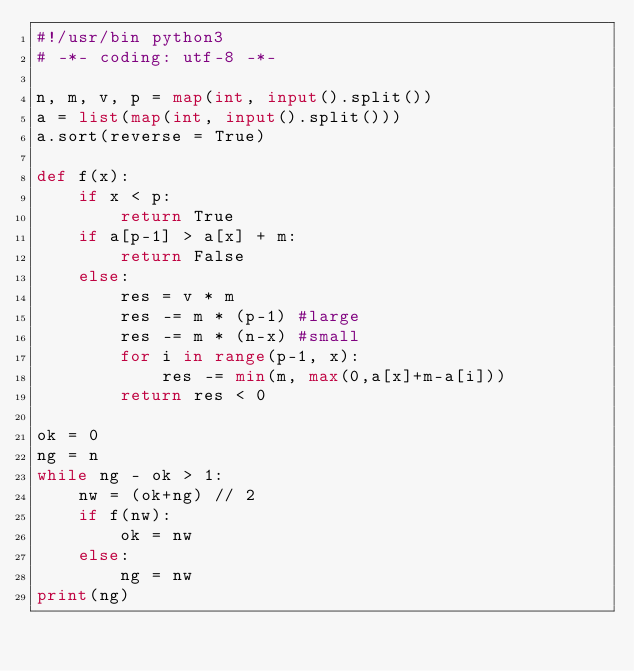Convert code to text. <code><loc_0><loc_0><loc_500><loc_500><_Python_>#!/usr/bin python3
# -*- coding: utf-8 -*-

n, m, v, p = map(int, input().split())
a = list(map(int, input().split()))
a.sort(reverse = True)

def f(x):
    if x < p:
        return True
    if a[p-1] > a[x] + m:
        return False
    else:
        res = v * m
        res -= m * (p-1) #large
        res -= m * (n-x) #small
        for i in range(p-1, x):
            res -= min(m, max(0,a[x]+m-a[i]))
        return res < 0

ok = 0
ng = n
while ng - ok > 1:
    nw = (ok+ng) // 2
    if f(nw):
        ok = nw
    else:
        ng = nw
print(ng)
</code> 